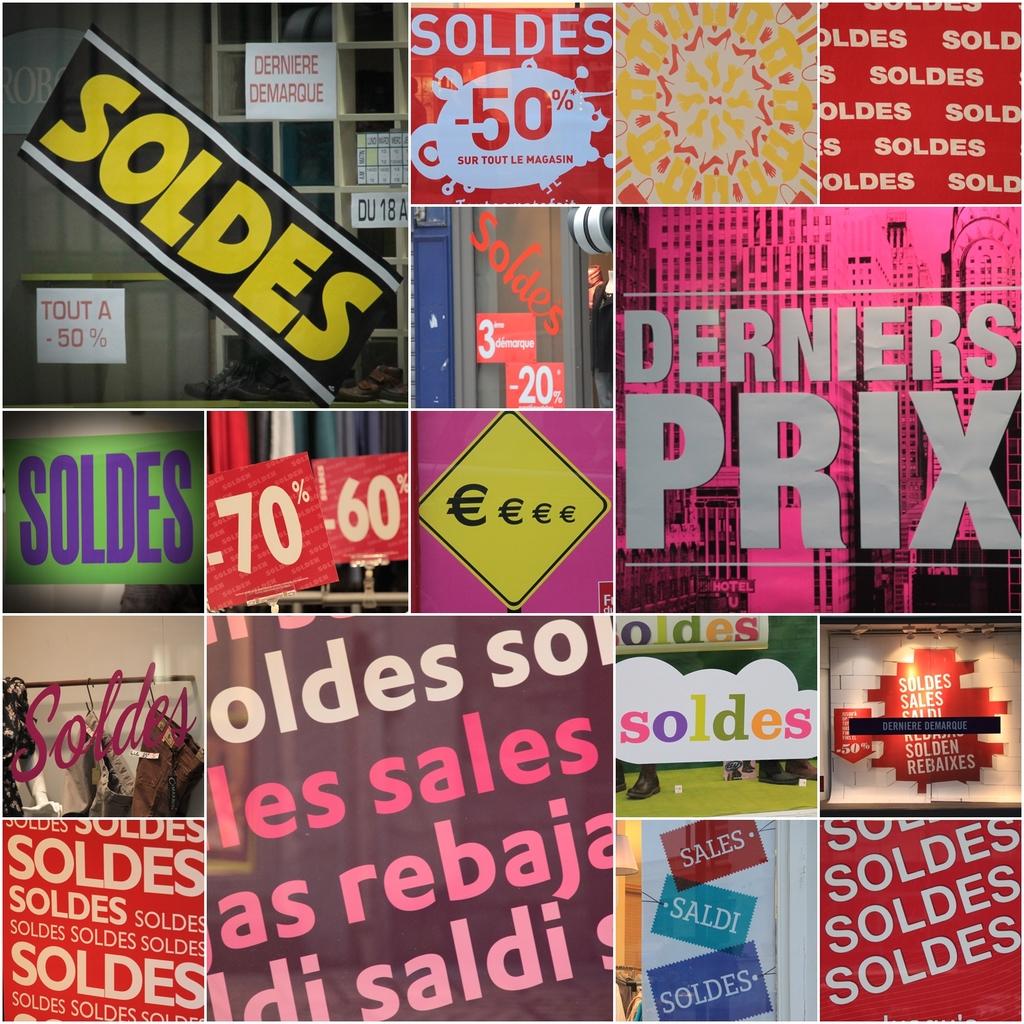What does the top left say in yellow writing?
Provide a succinct answer. Soldes. What is written in white on the bottom right hand side?
Your answer should be compact. Soldes. 